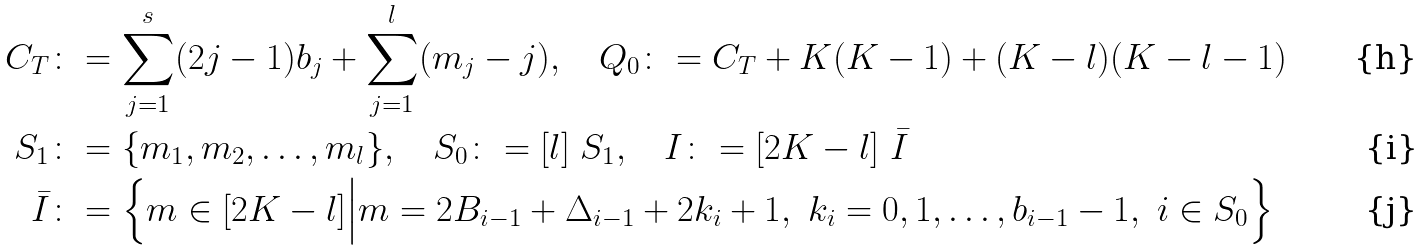<formula> <loc_0><loc_0><loc_500><loc_500>C _ { T } & \colon = \sum _ { j = 1 } ^ { s } ( 2 j - 1 ) b _ { j } + \sum _ { j = 1 } ^ { l } ( m _ { j } - j ) , \quad Q _ { 0 } \colon = C _ { T } + K ( K - 1 ) + ( K - l ) ( K - l - 1 ) \\ S _ { 1 } & \colon = \{ m _ { 1 } , m _ { 2 } , \dots , m _ { l } \} , \quad S _ { 0 } \colon = [ l ] \ S _ { 1 } , \quad I \colon = [ 2 K - l ] \ \bar { I } \\ \bar { I } & \colon = \left \{ m \in [ 2 K - l ] \Big | m = 2 B _ { i - 1 } + \Delta _ { i - 1 } + 2 k _ { i } + 1 , \ k _ { i } = 0 , 1 , \dots , b _ { i - 1 } - 1 , \ i \in S _ { 0 } \right \}</formula> 